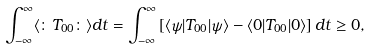Convert formula to latex. <formula><loc_0><loc_0><loc_500><loc_500>\int _ { - \infty } ^ { \infty } \langle \colon T _ { 0 0 } \colon \rangle d t = \int _ { - \infty } ^ { \infty } \left [ \langle \psi | T _ { 0 0 } | \psi \rangle - \langle 0 | T _ { 0 0 } | 0 \rangle \right ] d t \geq 0 ,</formula> 